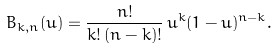<formula> <loc_0><loc_0><loc_500><loc_500>B _ { k , n } ( u ) = \frac { n ! } { k ! \, ( n - k ) ! } \, u ^ { k } ( 1 - u ) ^ { n - k } .</formula> 